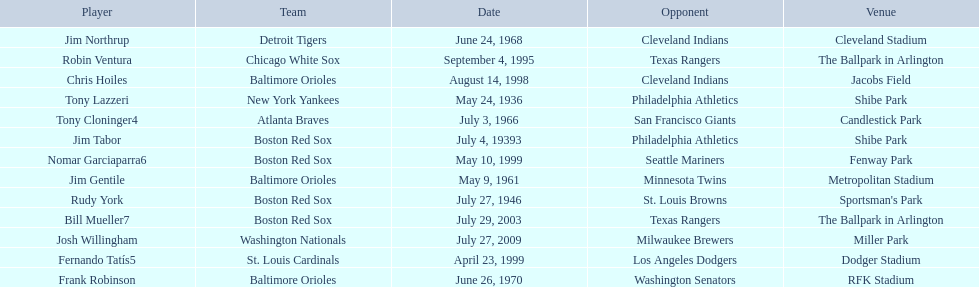What are the dates? May 24, 1936, July 4, 19393, July 27, 1946, May 9, 1961, July 3, 1966, June 24, 1968, June 26, 1970, September 4, 1995, August 14, 1998, April 23, 1999, May 10, 1999, July 29, 2003, July 27, 2009. Which date is in 1936? May 24, 1936. What player is listed for this date? Tony Lazzeri. 